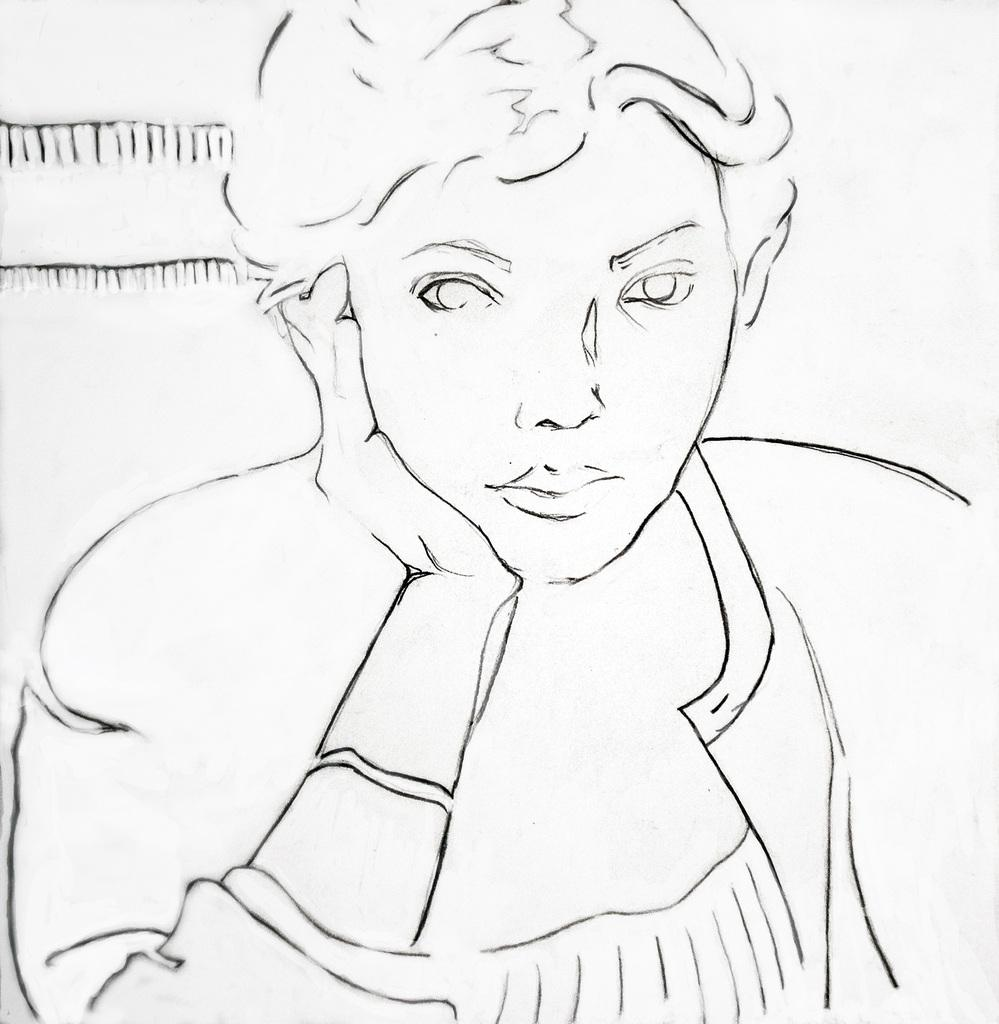What is the main subject of the image? There is a person sitting in the image. How is the person positioned in the image? The person is keeping a hand under their cheek. What color is the background of the image? The background of the image is white in color. Can you see the seashore in the background of the image? There is no seashore present in the image; the background is white in color. What type of cloth is the person wearing in the image? The provided facts do not mention any clothing worn by the person in the image. 